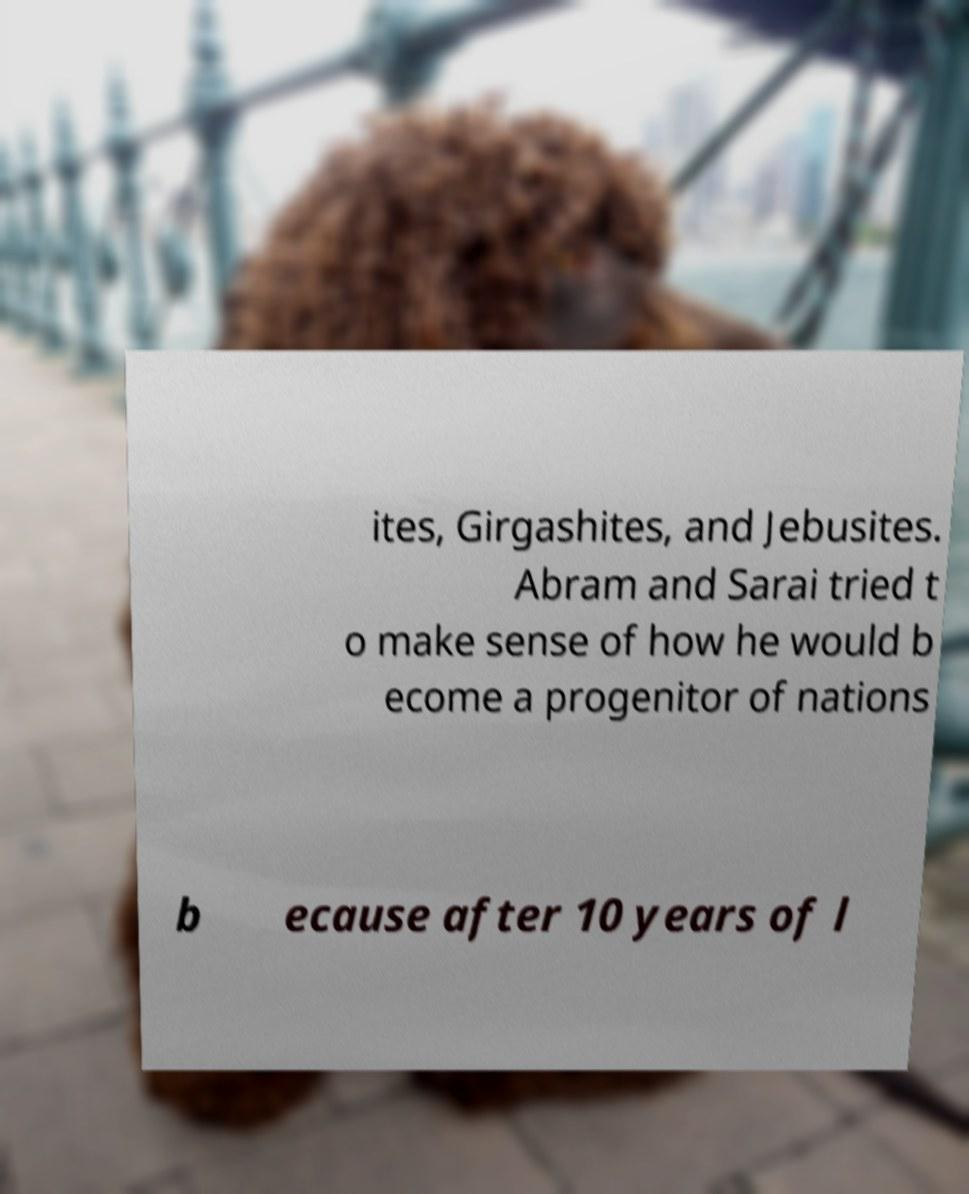For documentation purposes, I need the text within this image transcribed. Could you provide that? ites, Girgashites, and Jebusites. Abram and Sarai tried t o make sense of how he would b ecome a progenitor of nations b ecause after 10 years of l 